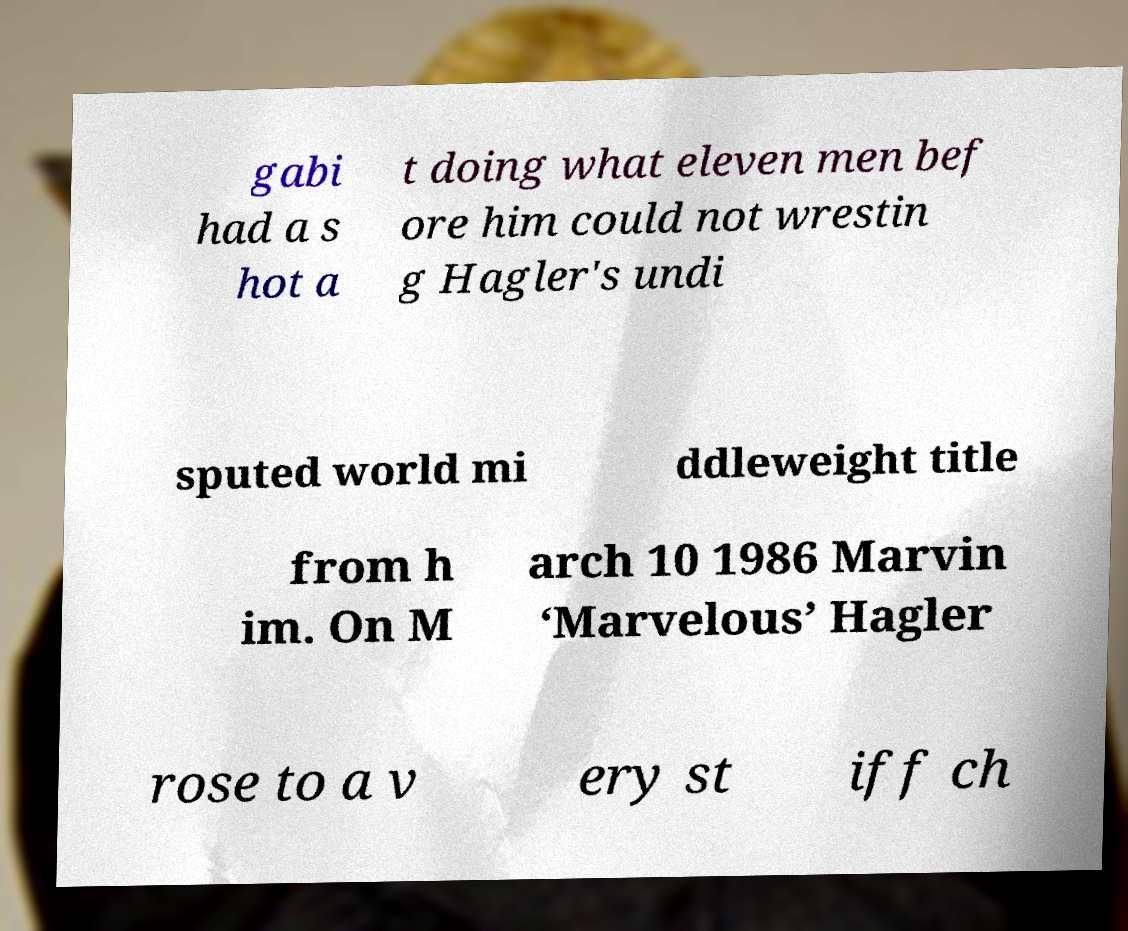Please read and relay the text visible in this image. What does it say? gabi had a s hot a t doing what eleven men bef ore him could not wrestin g Hagler's undi sputed world mi ddleweight title from h im. On M arch 10 1986 Marvin ‘Marvelous’ Hagler rose to a v ery st iff ch 